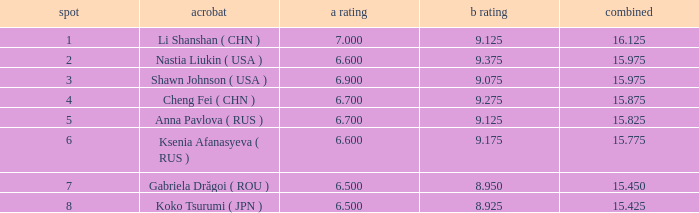What's the total that the position is less than 1? None. 